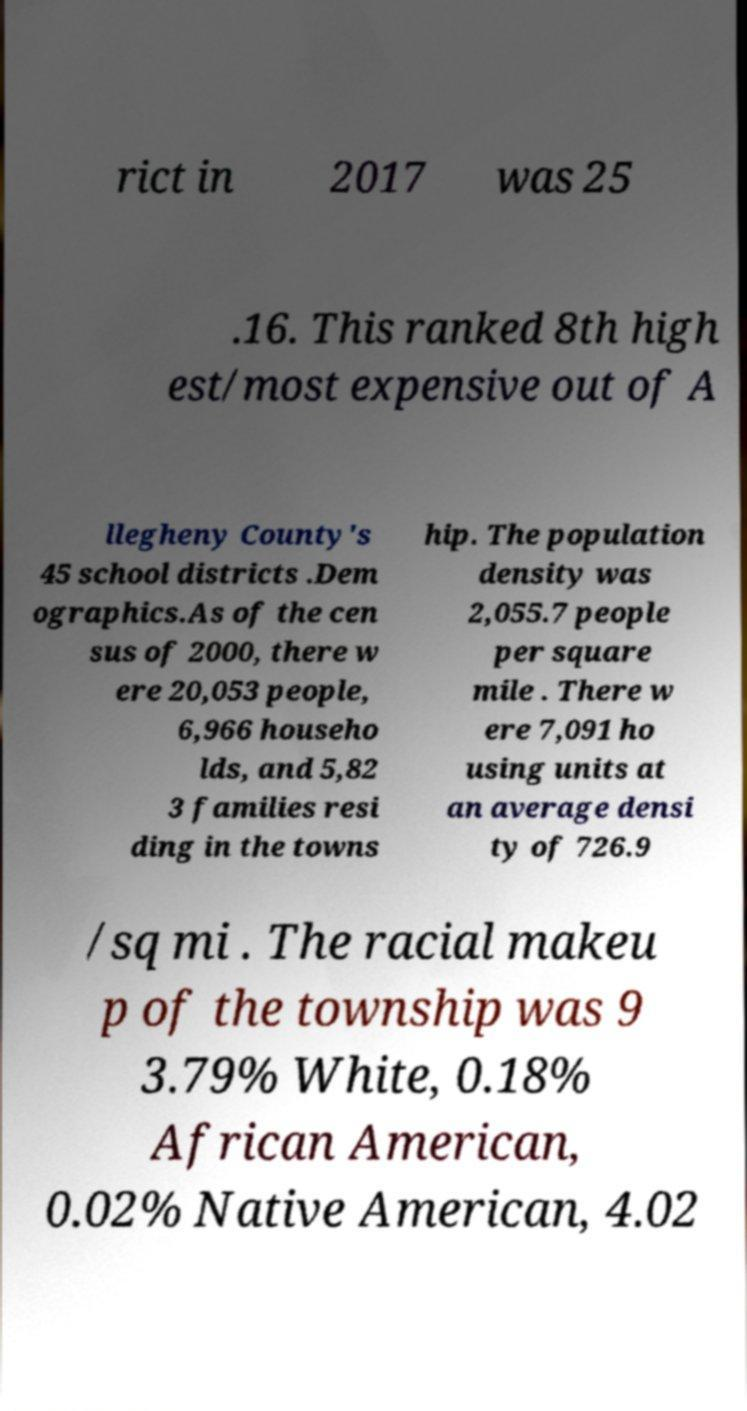Can you accurately transcribe the text from the provided image for me? rict in 2017 was 25 .16. This ranked 8th high est/most expensive out of A llegheny County's 45 school districts .Dem ographics.As of the cen sus of 2000, there w ere 20,053 people, 6,966 househo lds, and 5,82 3 families resi ding in the towns hip. The population density was 2,055.7 people per square mile . There w ere 7,091 ho using units at an average densi ty of 726.9 /sq mi . The racial makeu p of the township was 9 3.79% White, 0.18% African American, 0.02% Native American, 4.02 